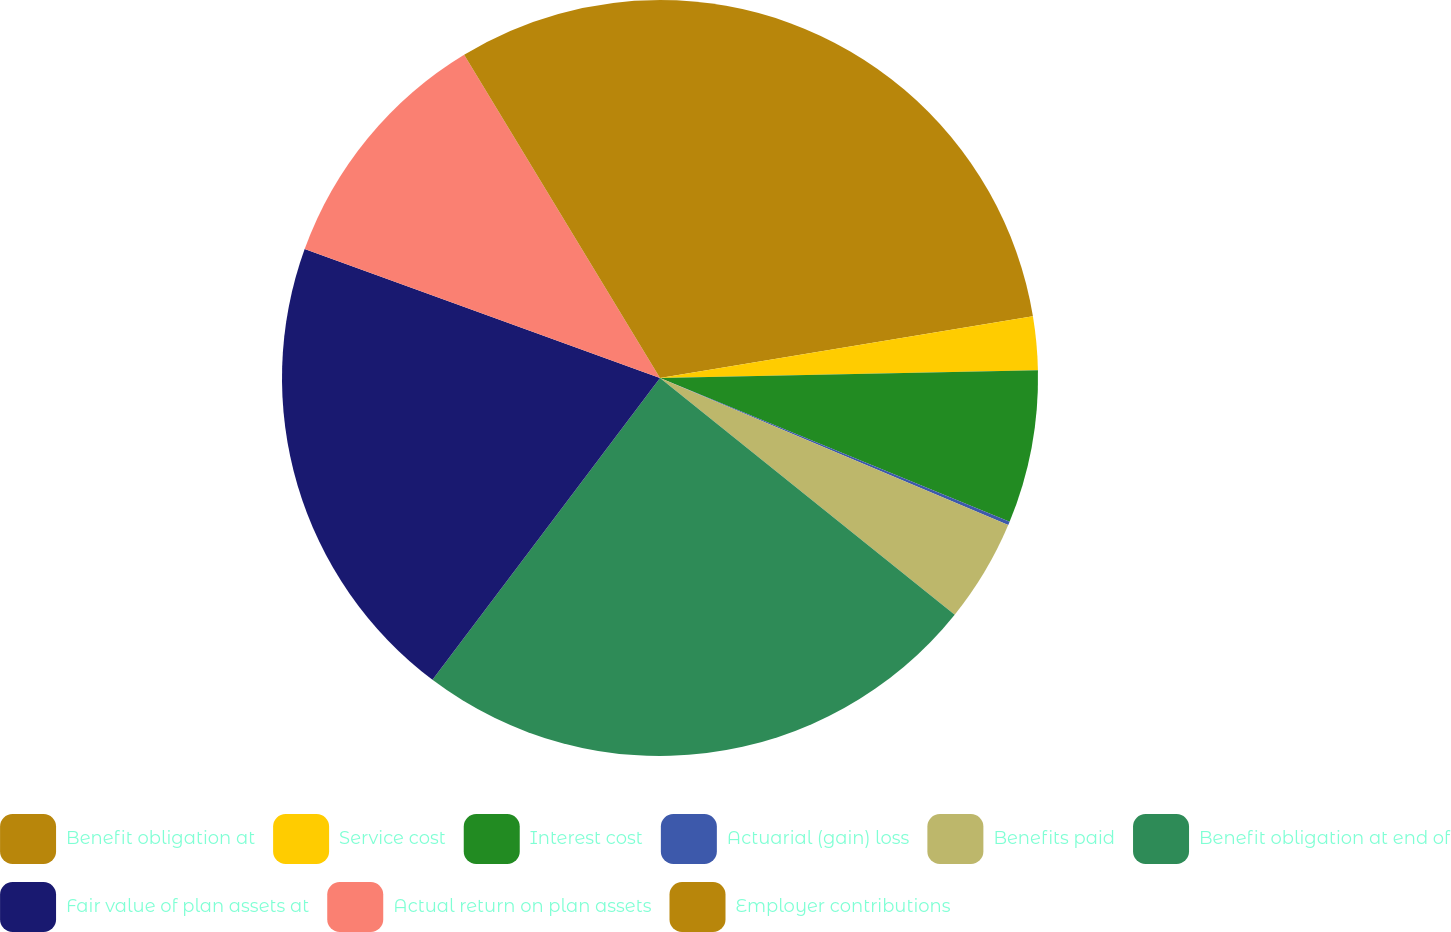Convert chart. <chart><loc_0><loc_0><loc_500><loc_500><pie_chart><fcel>Benefit obligation at<fcel>Service cost<fcel>Interest cost<fcel>Actuarial (gain) loss<fcel>Benefits paid<fcel>Benefit obligation at end of<fcel>Fair value of plan assets at<fcel>Actual return on plan assets<fcel>Employer contributions<nl><fcel>22.39%<fcel>2.28%<fcel>6.54%<fcel>0.15%<fcel>4.41%<fcel>24.51%<fcel>20.26%<fcel>10.79%<fcel>8.67%<nl></chart> 